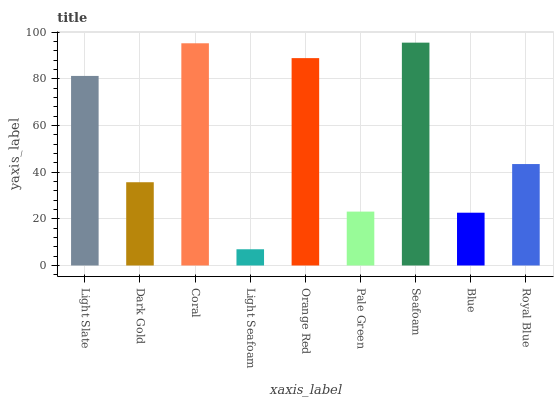Is Dark Gold the minimum?
Answer yes or no. No. Is Dark Gold the maximum?
Answer yes or no. No. Is Light Slate greater than Dark Gold?
Answer yes or no. Yes. Is Dark Gold less than Light Slate?
Answer yes or no. Yes. Is Dark Gold greater than Light Slate?
Answer yes or no. No. Is Light Slate less than Dark Gold?
Answer yes or no. No. Is Royal Blue the high median?
Answer yes or no. Yes. Is Royal Blue the low median?
Answer yes or no. Yes. Is Dark Gold the high median?
Answer yes or no. No. Is Blue the low median?
Answer yes or no. No. 